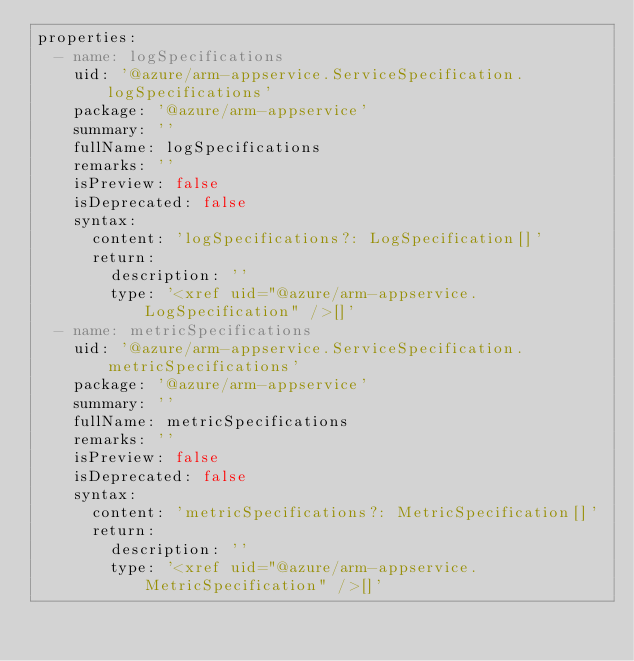Convert code to text. <code><loc_0><loc_0><loc_500><loc_500><_YAML_>properties:
  - name: logSpecifications
    uid: '@azure/arm-appservice.ServiceSpecification.logSpecifications'
    package: '@azure/arm-appservice'
    summary: ''
    fullName: logSpecifications
    remarks: ''
    isPreview: false
    isDeprecated: false
    syntax:
      content: 'logSpecifications?: LogSpecification[]'
      return:
        description: ''
        type: '<xref uid="@azure/arm-appservice.LogSpecification" />[]'
  - name: metricSpecifications
    uid: '@azure/arm-appservice.ServiceSpecification.metricSpecifications'
    package: '@azure/arm-appservice'
    summary: ''
    fullName: metricSpecifications
    remarks: ''
    isPreview: false
    isDeprecated: false
    syntax:
      content: 'metricSpecifications?: MetricSpecification[]'
      return:
        description: ''
        type: '<xref uid="@azure/arm-appservice.MetricSpecification" />[]'
</code> 